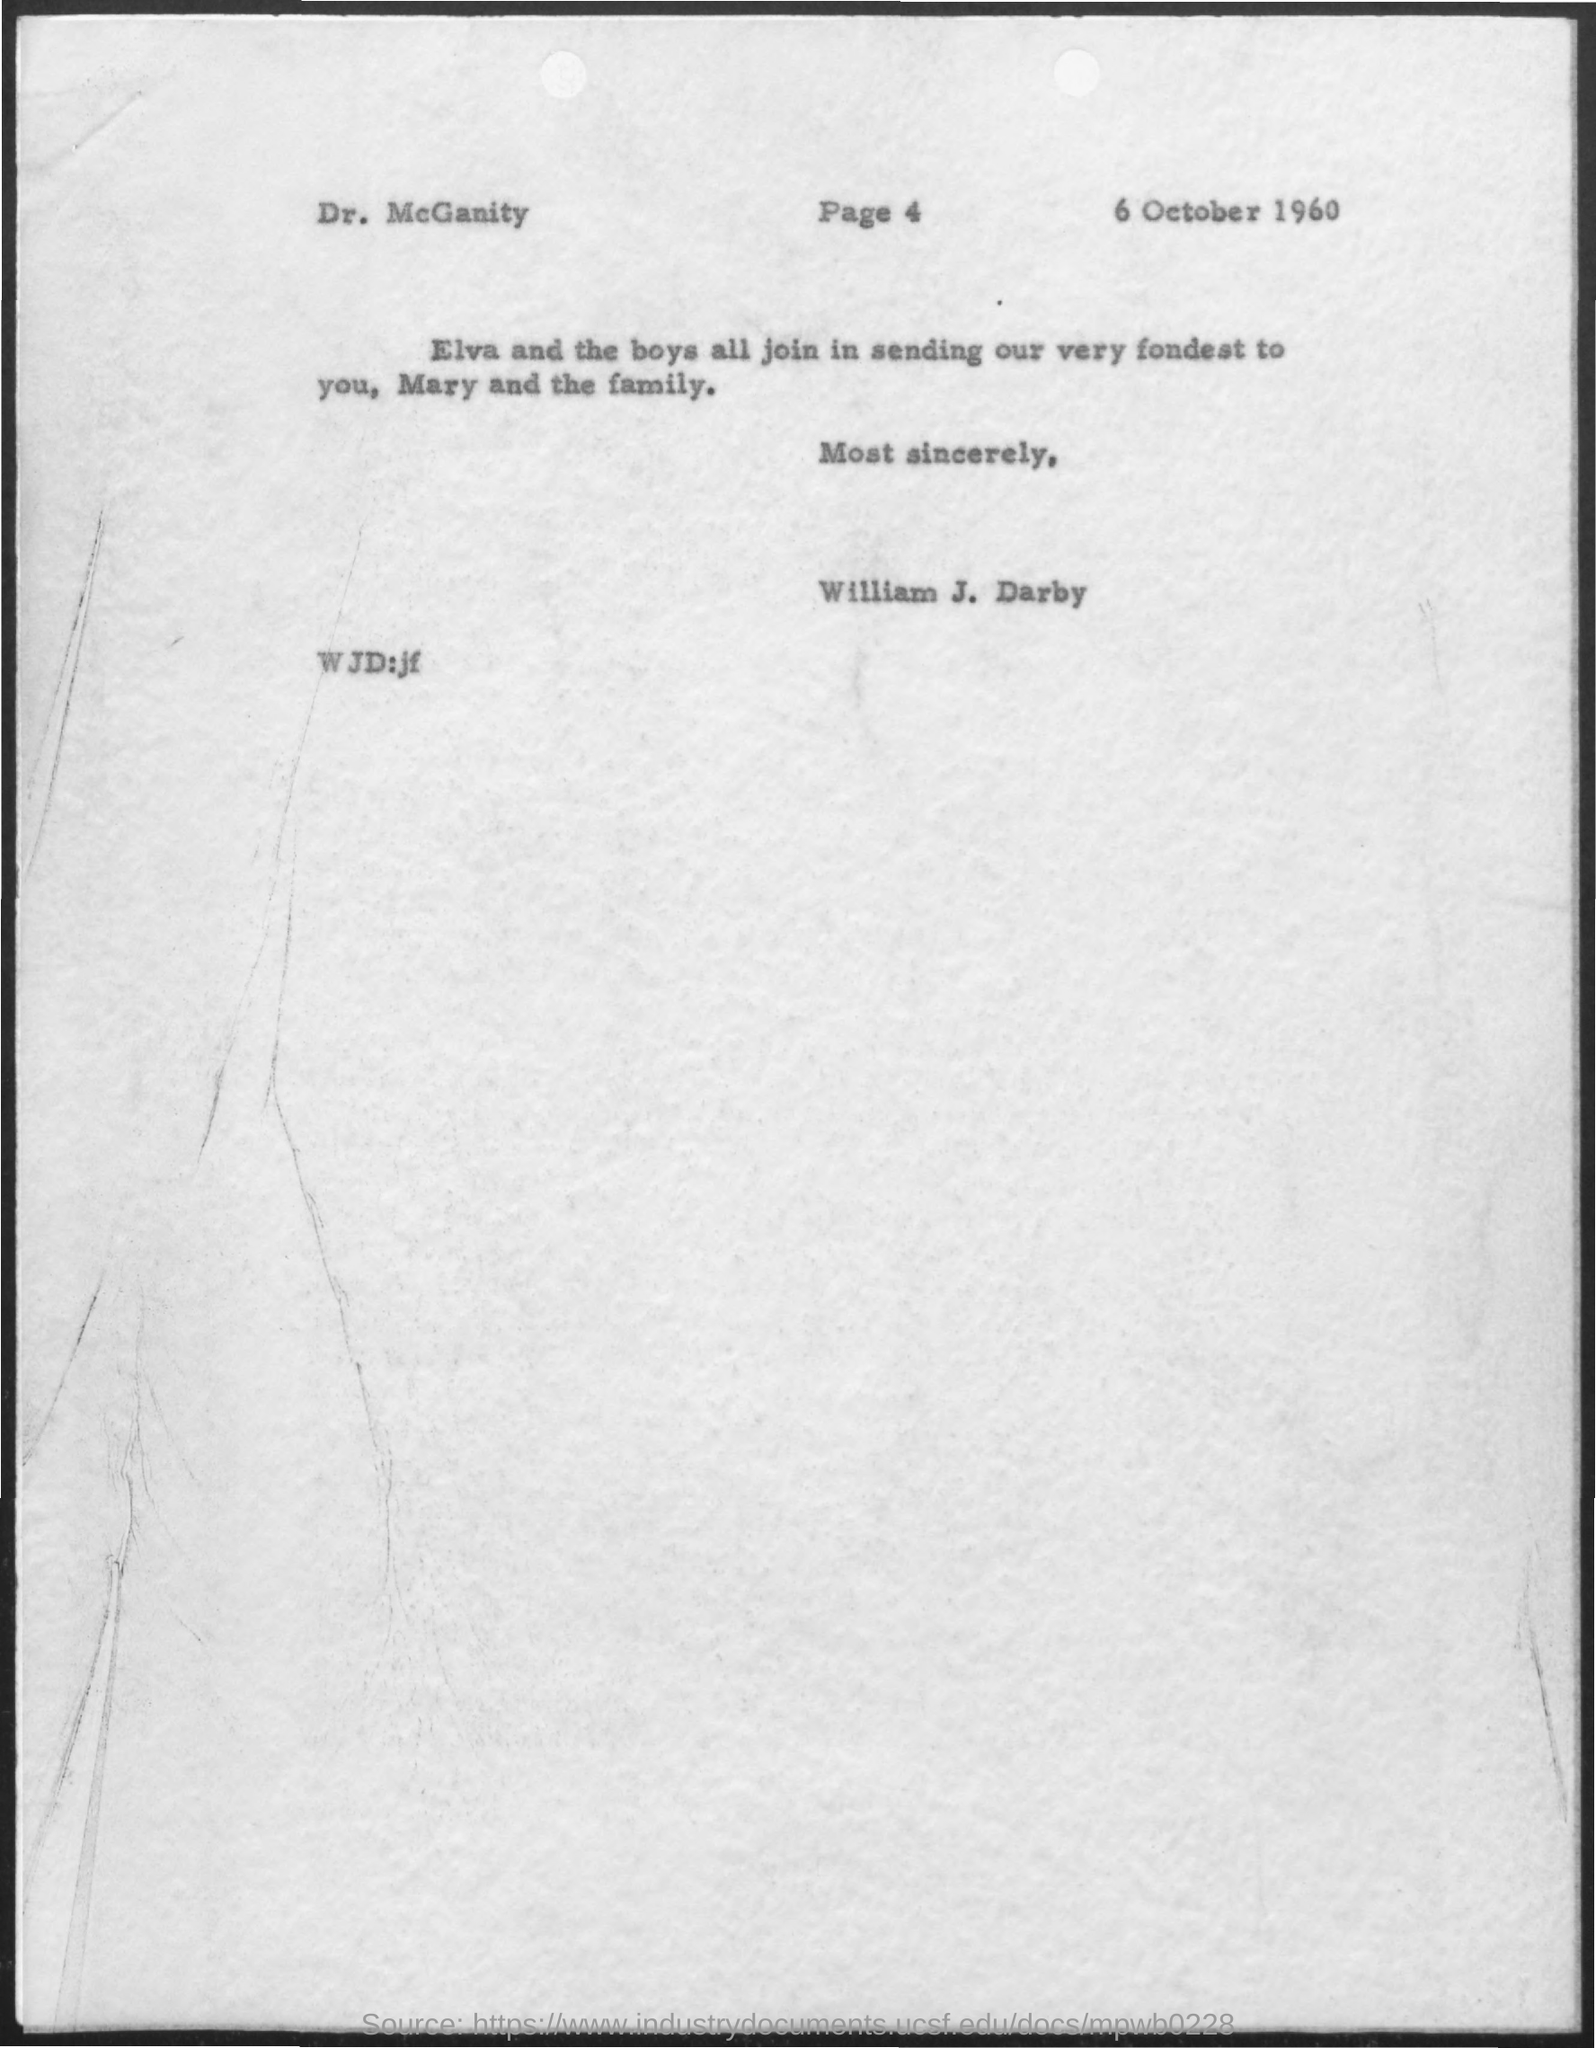Who is the addressee of this letter?
Give a very brief answer. Dr. McGanity. Who is the sender of this letter?
Your response must be concise. William J. Darby. What is the letter dated?
Ensure brevity in your answer.  6 October 1960. 